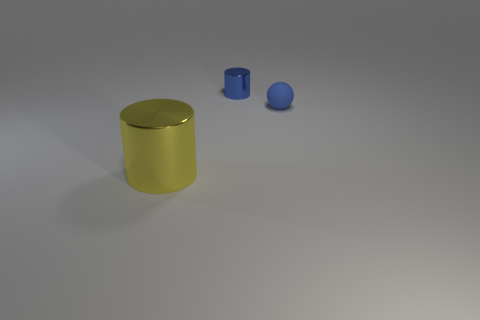Add 1 blue matte spheres. How many objects exist? 4 Subtract all cylinders. How many objects are left? 1 Add 2 large metal cylinders. How many large metal cylinders are left? 3 Add 1 big green cubes. How many big green cubes exist? 1 Subtract 0 green cylinders. How many objects are left? 3 Subtract all big purple cubes. Subtract all small blue matte things. How many objects are left? 2 